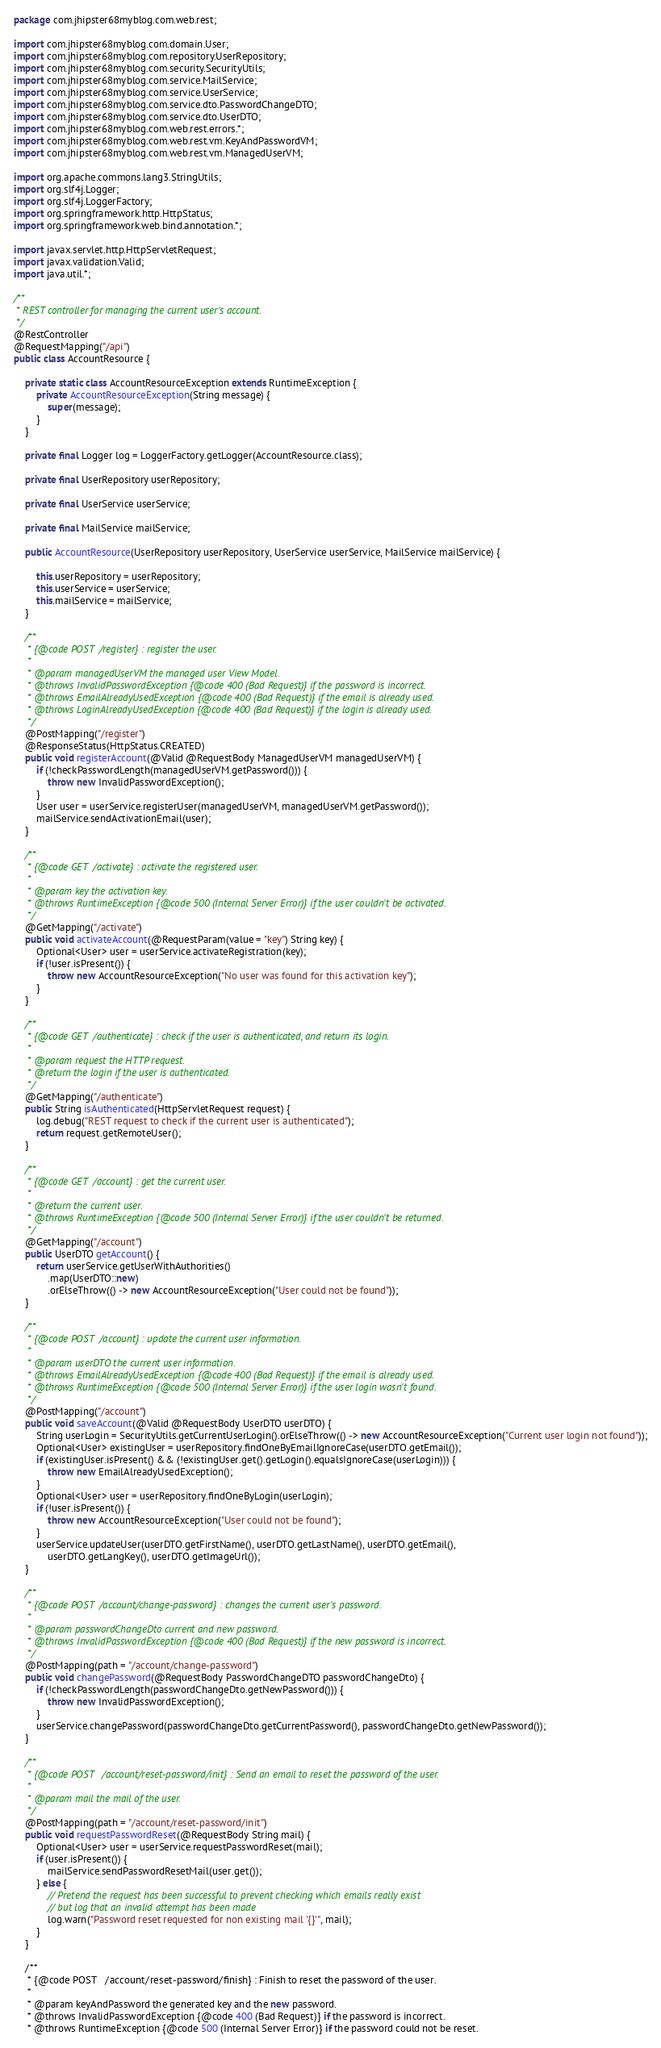Convert code to text. <code><loc_0><loc_0><loc_500><loc_500><_Java_>package com.jhipster68myblog.com.web.rest;

import com.jhipster68myblog.com.domain.User;
import com.jhipster68myblog.com.repository.UserRepository;
import com.jhipster68myblog.com.security.SecurityUtils;
import com.jhipster68myblog.com.service.MailService;
import com.jhipster68myblog.com.service.UserService;
import com.jhipster68myblog.com.service.dto.PasswordChangeDTO;
import com.jhipster68myblog.com.service.dto.UserDTO;
import com.jhipster68myblog.com.web.rest.errors.*;
import com.jhipster68myblog.com.web.rest.vm.KeyAndPasswordVM;
import com.jhipster68myblog.com.web.rest.vm.ManagedUserVM;

import org.apache.commons.lang3.StringUtils;
import org.slf4j.Logger;
import org.slf4j.LoggerFactory;
import org.springframework.http.HttpStatus;
import org.springframework.web.bind.annotation.*;

import javax.servlet.http.HttpServletRequest;
import javax.validation.Valid;
import java.util.*;

/**
 * REST controller for managing the current user's account.
 */
@RestController
@RequestMapping("/api")
public class AccountResource {

    private static class AccountResourceException extends RuntimeException {
        private AccountResourceException(String message) {
            super(message);
        }
    }

    private final Logger log = LoggerFactory.getLogger(AccountResource.class);

    private final UserRepository userRepository;

    private final UserService userService;

    private final MailService mailService;

    public AccountResource(UserRepository userRepository, UserService userService, MailService mailService) {

        this.userRepository = userRepository;
        this.userService = userService;
        this.mailService = mailService;
    }

    /**
     * {@code POST  /register} : register the user.
     *
     * @param managedUserVM the managed user View Model.
     * @throws InvalidPasswordException {@code 400 (Bad Request)} if the password is incorrect.
     * @throws EmailAlreadyUsedException {@code 400 (Bad Request)} if the email is already used.
     * @throws LoginAlreadyUsedException {@code 400 (Bad Request)} if the login is already used.
     */
    @PostMapping("/register")
    @ResponseStatus(HttpStatus.CREATED)
    public void registerAccount(@Valid @RequestBody ManagedUserVM managedUserVM) {
        if (!checkPasswordLength(managedUserVM.getPassword())) {
            throw new InvalidPasswordException();
        }
        User user = userService.registerUser(managedUserVM, managedUserVM.getPassword());
        mailService.sendActivationEmail(user);
    }

    /**
     * {@code GET  /activate} : activate the registered user.
     *
     * @param key the activation key.
     * @throws RuntimeException {@code 500 (Internal Server Error)} if the user couldn't be activated.
     */
    @GetMapping("/activate")
    public void activateAccount(@RequestParam(value = "key") String key) {
        Optional<User> user = userService.activateRegistration(key);
        if (!user.isPresent()) {
            throw new AccountResourceException("No user was found for this activation key");
        }
    }

    /**
     * {@code GET  /authenticate} : check if the user is authenticated, and return its login.
     *
     * @param request the HTTP request.
     * @return the login if the user is authenticated.
     */
    @GetMapping("/authenticate")
    public String isAuthenticated(HttpServletRequest request) {
        log.debug("REST request to check if the current user is authenticated");
        return request.getRemoteUser();
    }

    /**
     * {@code GET  /account} : get the current user.
     *
     * @return the current user.
     * @throws RuntimeException {@code 500 (Internal Server Error)} if the user couldn't be returned.
     */
    @GetMapping("/account")
    public UserDTO getAccount() {
        return userService.getUserWithAuthorities()
            .map(UserDTO::new)
            .orElseThrow(() -> new AccountResourceException("User could not be found"));
    }

    /**
     * {@code POST  /account} : update the current user information.
     *
     * @param userDTO the current user information.
     * @throws EmailAlreadyUsedException {@code 400 (Bad Request)} if the email is already used.
     * @throws RuntimeException {@code 500 (Internal Server Error)} if the user login wasn't found.
     */
    @PostMapping("/account")
    public void saveAccount(@Valid @RequestBody UserDTO userDTO) {
        String userLogin = SecurityUtils.getCurrentUserLogin().orElseThrow(() -> new AccountResourceException("Current user login not found"));
        Optional<User> existingUser = userRepository.findOneByEmailIgnoreCase(userDTO.getEmail());
        if (existingUser.isPresent() && (!existingUser.get().getLogin().equalsIgnoreCase(userLogin))) {
            throw new EmailAlreadyUsedException();
        }
        Optional<User> user = userRepository.findOneByLogin(userLogin);
        if (!user.isPresent()) {
            throw new AccountResourceException("User could not be found");
        }
        userService.updateUser(userDTO.getFirstName(), userDTO.getLastName(), userDTO.getEmail(),
            userDTO.getLangKey(), userDTO.getImageUrl());
    }

    /**
     * {@code POST  /account/change-password} : changes the current user's password.
     *
     * @param passwordChangeDto current and new password.
     * @throws InvalidPasswordException {@code 400 (Bad Request)} if the new password is incorrect.
     */
    @PostMapping(path = "/account/change-password")
    public void changePassword(@RequestBody PasswordChangeDTO passwordChangeDto) {
        if (!checkPasswordLength(passwordChangeDto.getNewPassword())) {
            throw new InvalidPasswordException();
        }
        userService.changePassword(passwordChangeDto.getCurrentPassword(), passwordChangeDto.getNewPassword());
    }

    /**
     * {@code POST   /account/reset-password/init} : Send an email to reset the password of the user.
     *
     * @param mail the mail of the user.
     */
    @PostMapping(path = "/account/reset-password/init")
    public void requestPasswordReset(@RequestBody String mail) {
        Optional<User> user = userService.requestPasswordReset(mail);
        if (user.isPresent()) {
            mailService.sendPasswordResetMail(user.get());
        } else {
            // Pretend the request has been successful to prevent checking which emails really exist
            // but log that an invalid attempt has been made
            log.warn("Password reset requested for non existing mail '{}'", mail);
        }
    }

    /**
     * {@code POST   /account/reset-password/finish} : Finish to reset the password of the user.
     *
     * @param keyAndPassword the generated key and the new password.
     * @throws InvalidPasswordException {@code 400 (Bad Request)} if the password is incorrect.
     * @throws RuntimeException {@code 500 (Internal Server Error)} if the password could not be reset.</code> 